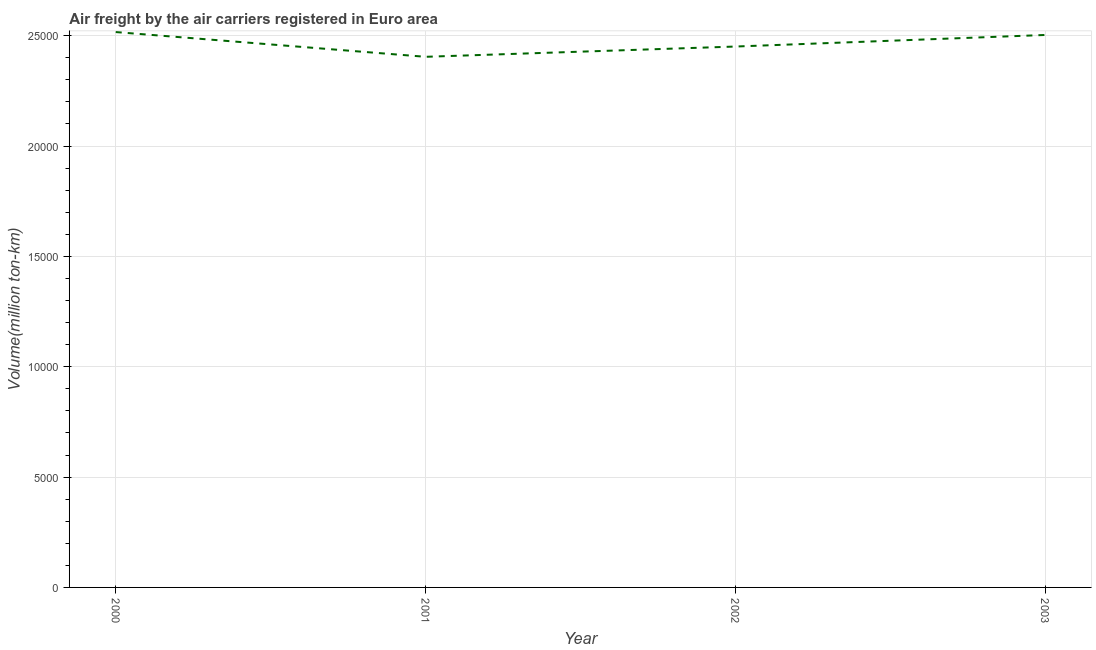What is the air freight in 2001?
Your response must be concise. 2.40e+04. Across all years, what is the maximum air freight?
Keep it short and to the point. 2.52e+04. Across all years, what is the minimum air freight?
Give a very brief answer. 2.40e+04. What is the sum of the air freight?
Offer a terse response. 9.88e+04. What is the difference between the air freight in 2000 and 2002?
Ensure brevity in your answer.  656.07. What is the average air freight per year?
Offer a very short reply. 2.47e+04. What is the median air freight?
Offer a terse response. 2.48e+04. In how many years, is the air freight greater than 16000 million ton-km?
Provide a succinct answer. 4. What is the ratio of the air freight in 2000 to that in 2002?
Give a very brief answer. 1.03. What is the difference between the highest and the second highest air freight?
Make the answer very short. 131.91. Is the sum of the air freight in 2000 and 2001 greater than the maximum air freight across all years?
Keep it short and to the point. Yes. What is the difference between the highest and the lowest air freight?
Provide a short and direct response. 1120.93. Does the air freight monotonically increase over the years?
Make the answer very short. No. What is the difference between two consecutive major ticks on the Y-axis?
Provide a short and direct response. 5000. Are the values on the major ticks of Y-axis written in scientific E-notation?
Provide a short and direct response. No. Does the graph contain any zero values?
Your answer should be compact. No. What is the title of the graph?
Provide a succinct answer. Air freight by the air carriers registered in Euro area. What is the label or title of the Y-axis?
Provide a short and direct response. Volume(million ton-km). What is the Volume(million ton-km) in 2000?
Your answer should be very brief. 2.52e+04. What is the Volume(million ton-km) in 2001?
Keep it short and to the point. 2.40e+04. What is the Volume(million ton-km) of 2002?
Your response must be concise. 2.45e+04. What is the Volume(million ton-km) of 2003?
Make the answer very short. 2.50e+04. What is the difference between the Volume(million ton-km) in 2000 and 2001?
Offer a terse response. 1120.93. What is the difference between the Volume(million ton-km) in 2000 and 2002?
Your answer should be very brief. 656.07. What is the difference between the Volume(million ton-km) in 2000 and 2003?
Offer a terse response. 131.91. What is the difference between the Volume(million ton-km) in 2001 and 2002?
Keep it short and to the point. -464.86. What is the difference between the Volume(million ton-km) in 2001 and 2003?
Provide a succinct answer. -989.02. What is the difference between the Volume(million ton-km) in 2002 and 2003?
Give a very brief answer. -524.16. What is the ratio of the Volume(million ton-km) in 2000 to that in 2001?
Provide a short and direct response. 1.05. What is the ratio of the Volume(million ton-km) in 2002 to that in 2003?
Provide a short and direct response. 0.98. 